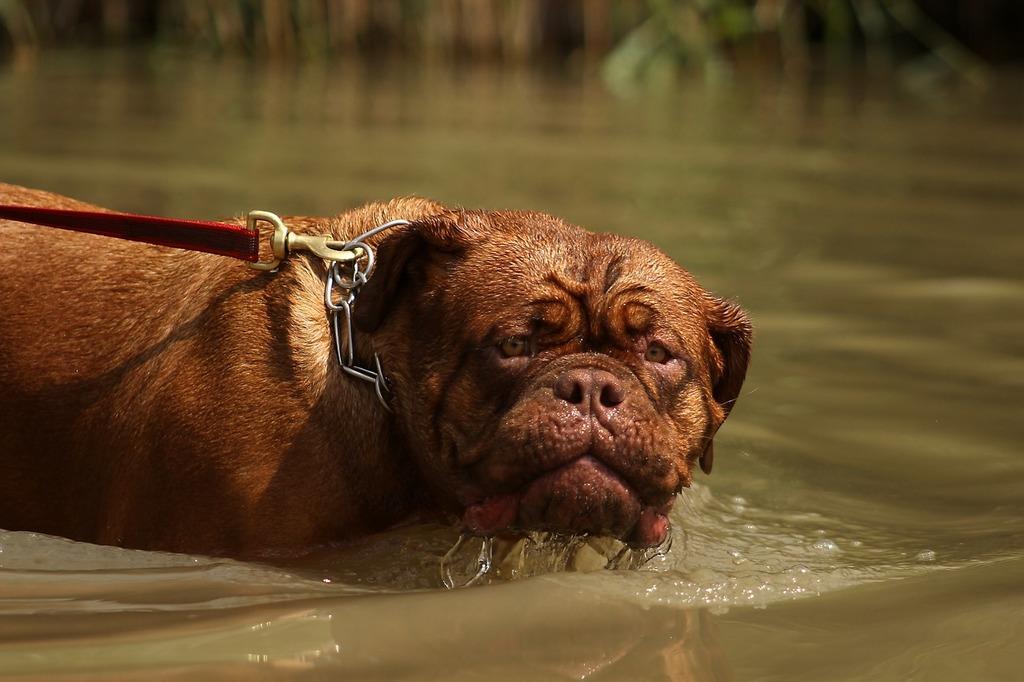Describe this image in one or two sentences. In this picture there is a dog in the water. The background is blurred. 